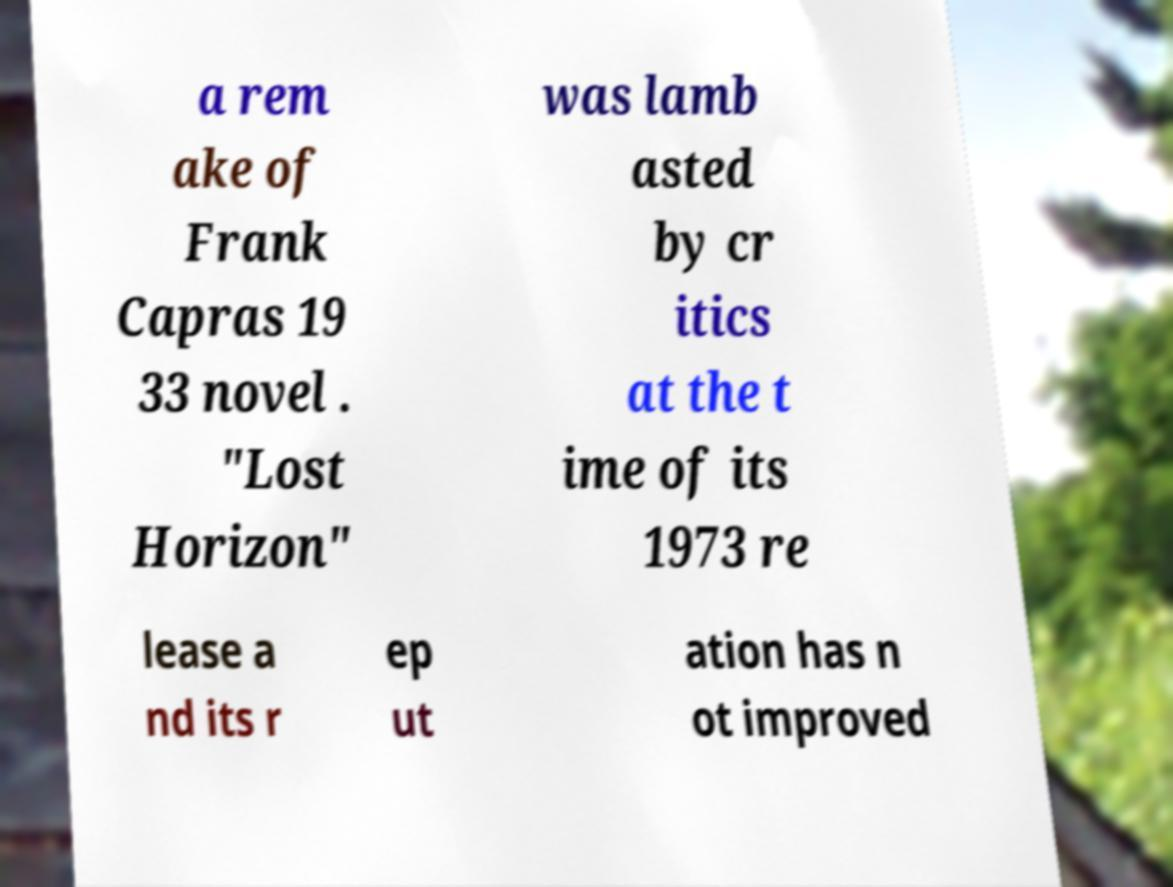Could you assist in decoding the text presented in this image and type it out clearly? a rem ake of Frank Capras 19 33 novel . "Lost Horizon" was lamb asted by cr itics at the t ime of its 1973 re lease a nd its r ep ut ation has n ot improved 